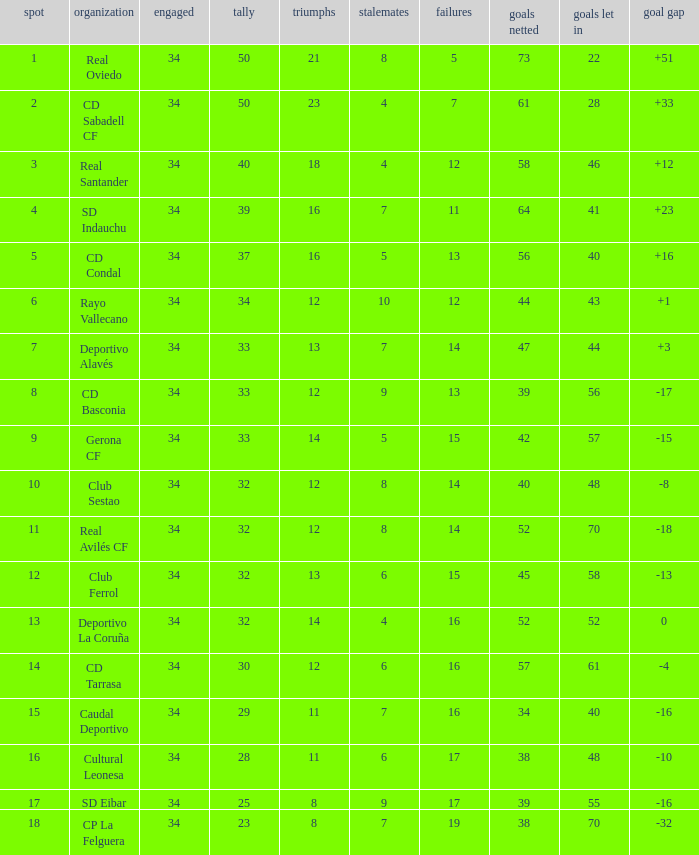Could you parse the entire table? {'header': ['spot', 'organization', 'engaged', 'tally', 'triumphs', 'stalemates', 'failures', 'goals netted', 'goals let in', 'goal gap'], 'rows': [['1', 'Real Oviedo', '34', '50', '21', '8', '5', '73', '22', '+51'], ['2', 'CD Sabadell CF', '34', '50', '23', '4', '7', '61', '28', '+33'], ['3', 'Real Santander', '34', '40', '18', '4', '12', '58', '46', '+12'], ['4', 'SD Indauchu', '34', '39', '16', '7', '11', '64', '41', '+23'], ['5', 'CD Condal', '34', '37', '16', '5', '13', '56', '40', '+16'], ['6', 'Rayo Vallecano', '34', '34', '12', '10', '12', '44', '43', '+1'], ['7', 'Deportivo Alavés', '34', '33', '13', '7', '14', '47', '44', '+3'], ['8', 'CD Basconia', '34', '33', '12', '9', '13', '39', '56', '-17'], ['9', 'Gerona CF', '34', '33', '14', '5', '15', '42', '57', '-15'], ['10', 'Club Sestao', '34', '32', '12', '8', '14', '40', '48', '-8'], ['11', 'Real Avilés CF', '34', '32', '12', '8', '14', '52', '70', '-18'], ['12', 'Club Ferrol', '34', '32', '13', '6', '15', '45', '58', '-13'], ['13', 'Deportivo La Coruña', '34', '32', '14', '4', '16', '52', '52', '0'], ['14', 'CD Tarrasa', '34', '30', '12', '6', '16', '57', '61', '-4'], ['15', 'Caudal Deportivo', '34', '29', '11', '7', '16', '34', '40', '-16'], ['16', 'Cultural Leonesa', '34', '28', '11', '6', '17', '38', '48', '-10'], ['17', 'SD Eibar', '34', '25', '8', '9', '17', '39', '55', '-16'], ['18', 'CP La Felguera', '34', '23', '8', '7', '19', '38', '70', '-32']]} How many Goals against have Played more than 34? 0.0. 